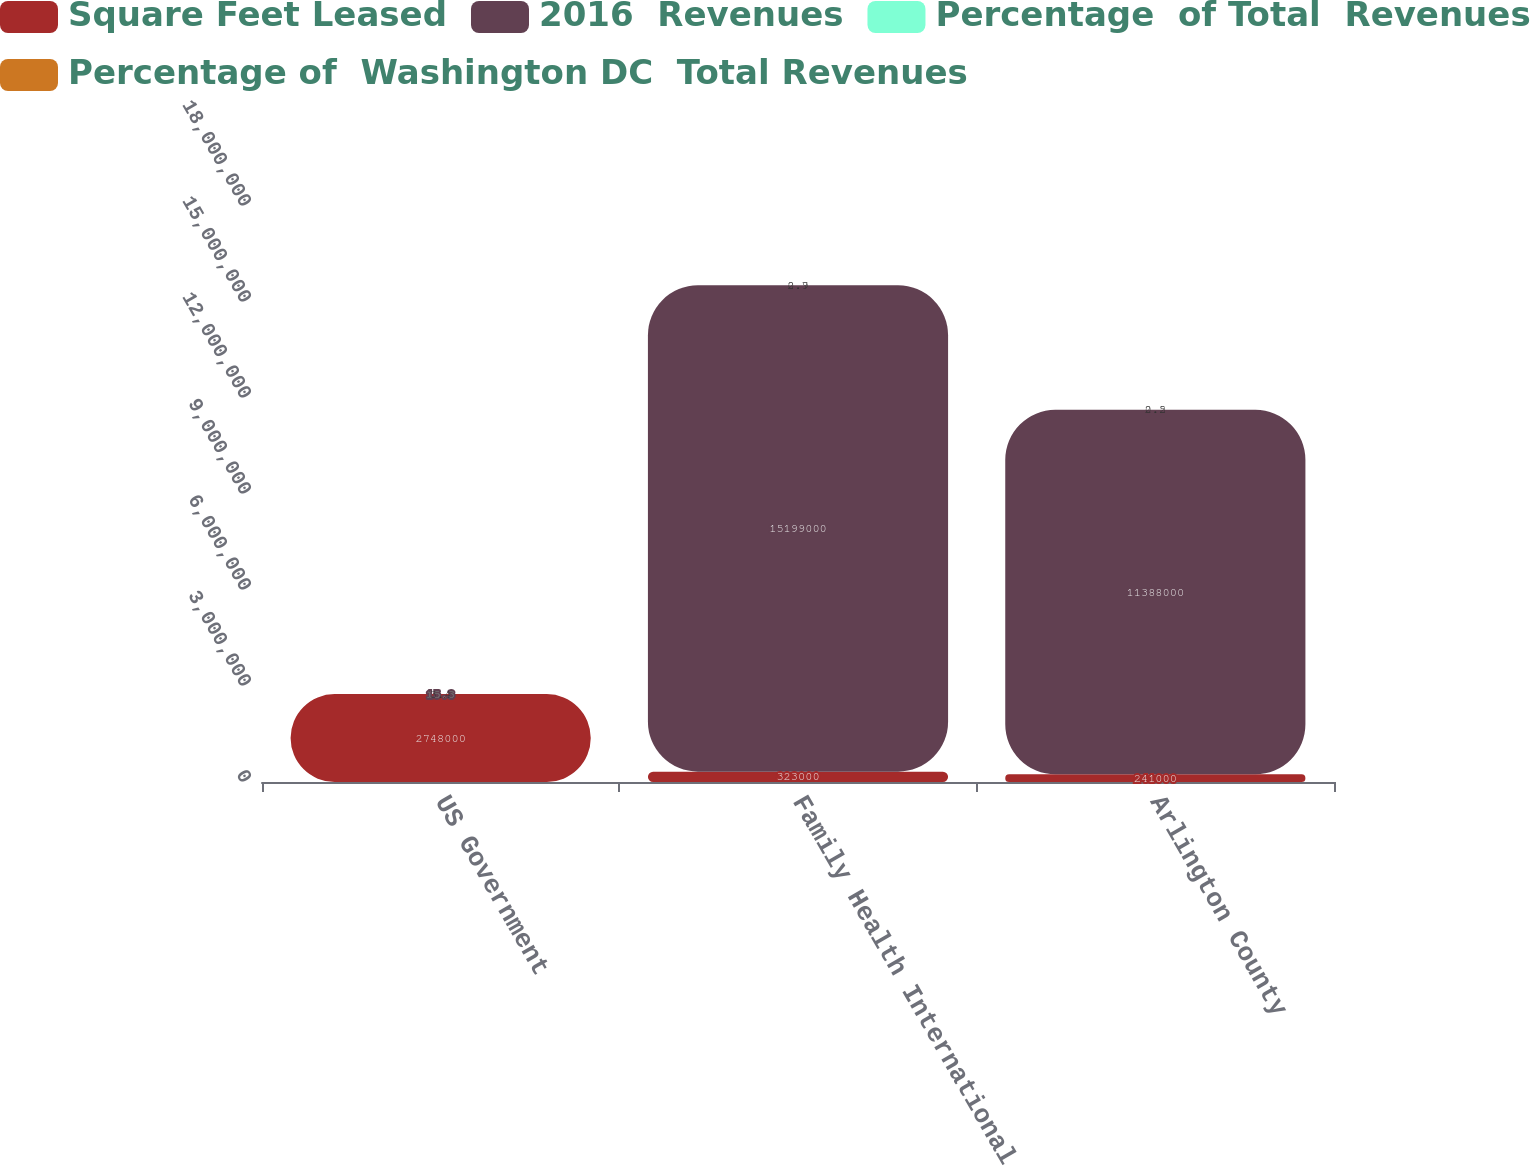Convert chart. <chart><loc_0><loc_0><loc_500><loc_500><stacked_bar_chart><ecel><fcel>US Government<fcel>Family Health International<fcel>Arlington County<nl><fcel>Square Feet Leased<fcel>2.748e+06<fcel>323000<fcel>241000<nl><fcel>2016  Revenues<fcel>15.3<fcel>1.5199e+07<fcel>1.1388e+07<nl><fcel>Percentage  of Total  Revenues<fcel>15.3<fcel>2.9<fcel>2.2<nl><fcel>Percentage of  Washington DC  Total Revenues<fcel>3.4<fcel>0.7<fcel>0.5<nl></chart> 